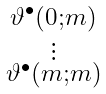Convert formula to latex. <formula><loc_0><loc_0><loc_500><loc_500>\begin{smallmatrix} \vartheta ^ { \bullet } ( 0 ; m ) \\ \vdots \\ \vartheta ^ { \bullet } ( m ; m ) \end{smallmatrix}</formula> 